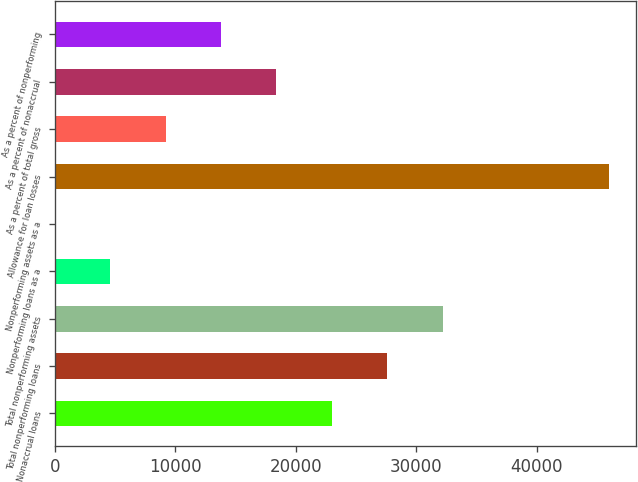Convert chart. <chart><loc_0><loc_0><loc_500><loc_500><bar_chart><fcel>Nonaccrual loans<fcel>Total nonperforming loans<fcel>Total nonperforming assets<fcel>Nonperforming loans as a<fcel>Nonperforming assets as a<fcel>Allowance for loan losses<fcel>As a percent of total gross<fcel>As a percent of nonaccrual<fcel>As a percent of nonperforming<nl><fcel>23000.3<fcel>27600.2<fcel>32200.2<fcel>4600.54<fcel>0.6<fcel>46000<fcel>9200.48<fcel>18400.4<fcel>13800.4<nl></chart> 